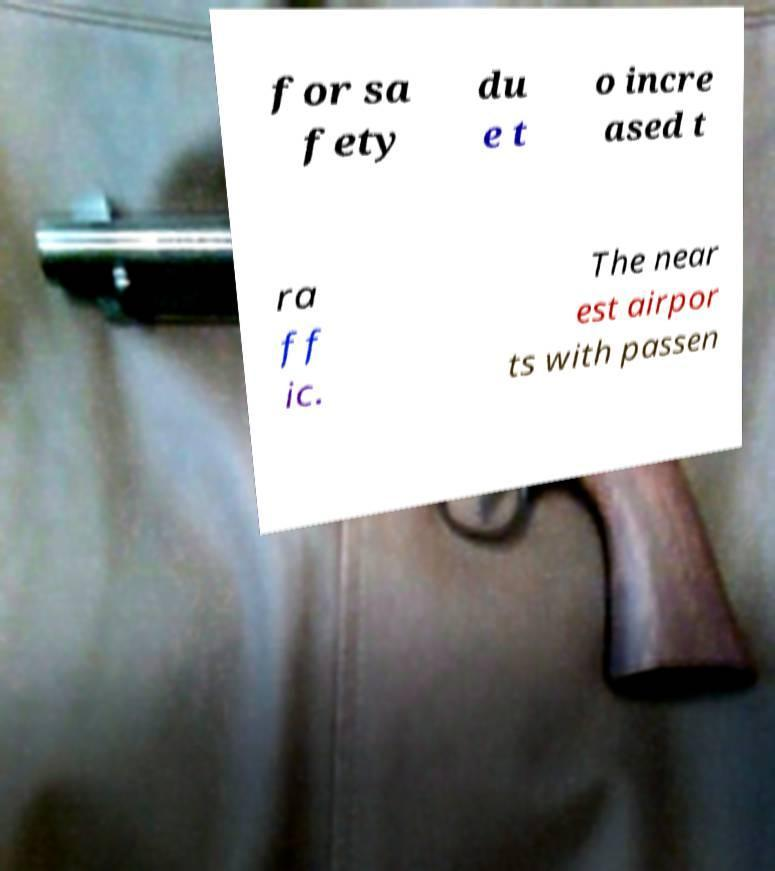Could you extract and type out the text from this image? for sa fety du e t o incre ased t ra ff ic. The near est airpor ts with passen 